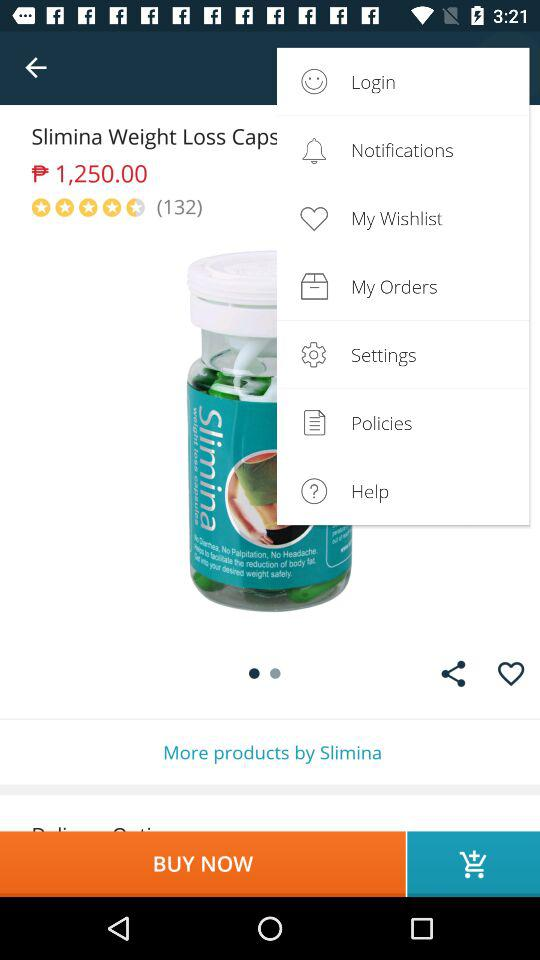What is the star rating of Slimina Weight Loss Capsules? The rating of Slimina Weight Loss Capsules is 4.5 stars. 